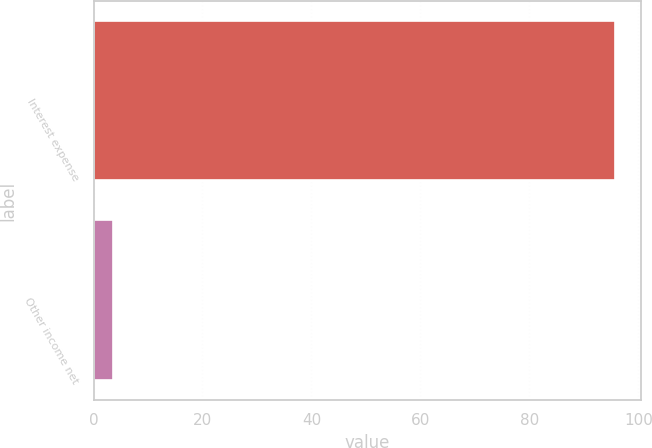Convert chart to OTSL. <chart><loc_0><loc_0><loc_500><loc_500><bar_chart><fcel>Interest expense<fcel>Other income net<nl><fcel>95.7<fcel>3.5<nl></chart> 